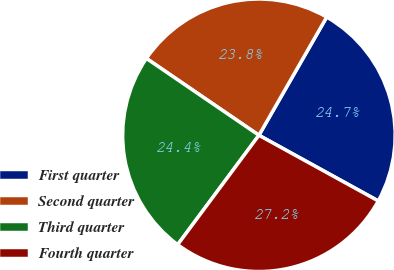<chart> <loc_0><loc_0><loc_500><loc_500><pie_chart><fcel>First quarter<fcel>Second quarter<fcel>Third quarter<fcel>Fourth quarter<nl><fcel>24.72%<fcel>23.75%<fcel>24.37%<fcel>27.16%<nl></chart> 